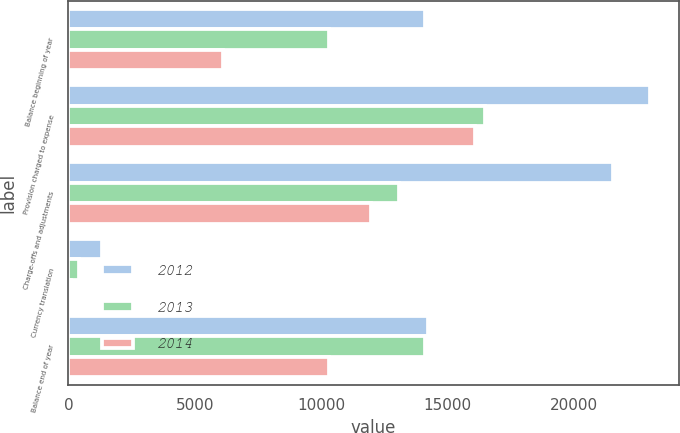Convert chart. <chart><loc_0><loc_0><loc_500><loc_500><stacked_bar_chart><ecel><fcel>Balance beginning of year<fcel>Provision charged to expense<fcel>Charge-offs and adjustments<fcel>Currency translation<fcel>Balance end of year<nl><fcel>2012<fcel>14116<fcel>22990<fcel>21546<fcel>1348<fcel>14212<nl><fcel>2013<fcel>10322<fcel>16451<fcel>13072<fcel>415<fcel>14116<nl><fcel>2014<fcel>6103<fcel>16094<fcel>11977<fcel>102<fcel>10322<nl></chart> 